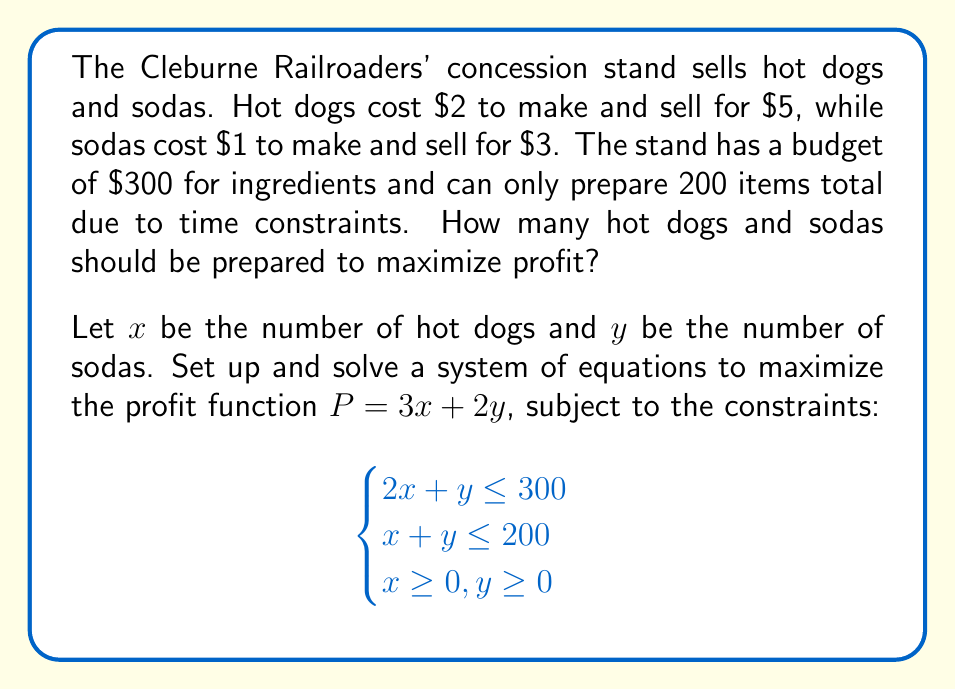Teach me how to tackle this problem. 1) First, let's graph the constraints:
   $$2x + y = 300$$ (Budget constraint)
   $$x + y = 200$$ (Time constraint)

2) The feasible region is bounded by these lines and the x and y axes.

3) The corner points of this region are:
   (0, 0), (0, 200), (100, 100), (150, 0)

4) The profit function is $P = 3x + 2y$. We need to evaluate this at each corner point:
   
   At (0, 0): $P = 3(0) + 2(0) = 0$
   At (0, 200): $P = 3(0) + 2(200) = 400$
   At (100, 100): $P = 3(100) + 2(100) = 500$
   At (150, 0): $P = 3(150) + 2(0) = 450$

5) The maximum profit occurs at the point (100, 100).

Therefore, to maximize profit, the concession stand should prepare 100 hot dogs and 100 sodas.

6) Let's verify the constraints:
   Budget: $2(100) + 1(100) = 300$ (uses exactly $300)
   Time: $100 + 100 = 200$ (prepares exactly 200 items)

7) The maximum profit is:
   $P = 3(100) + 2(100) = 300 + 200 = 500$
Answer: 100 hot dogs and 100 sodas; $500 profit 